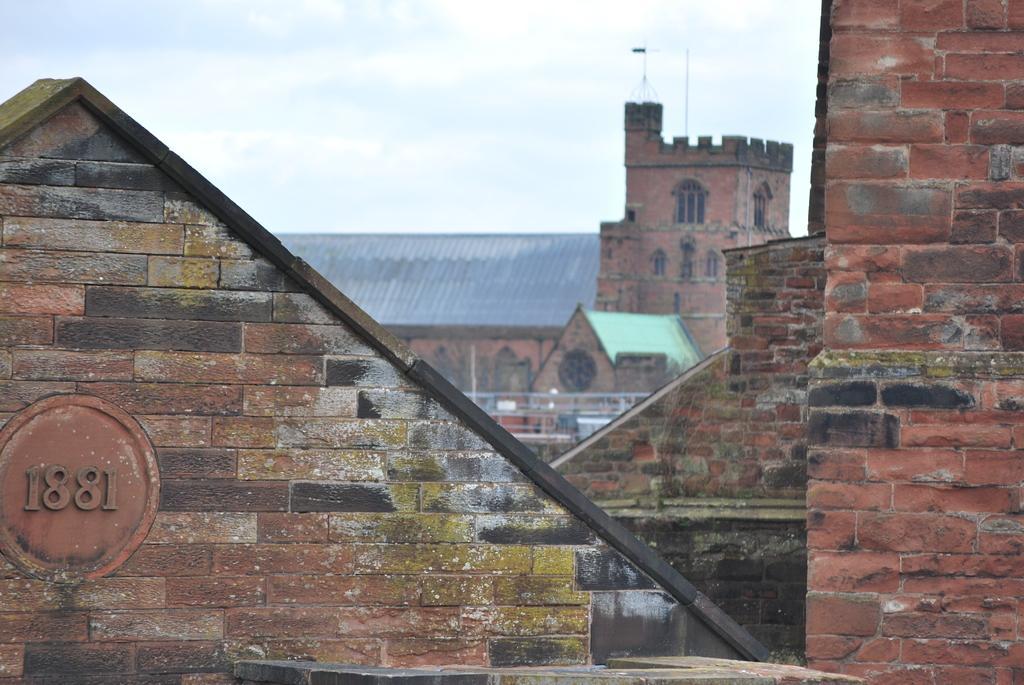Could you give a brief overview of what you see in this image? In this image I can see few buildings in brown and gray color and I can also few poles. In the background the sky is in white color. 